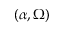<formula> <loc_0><loc_0><loc_500><loc_500>( \alpha , \Omega )</formula> 